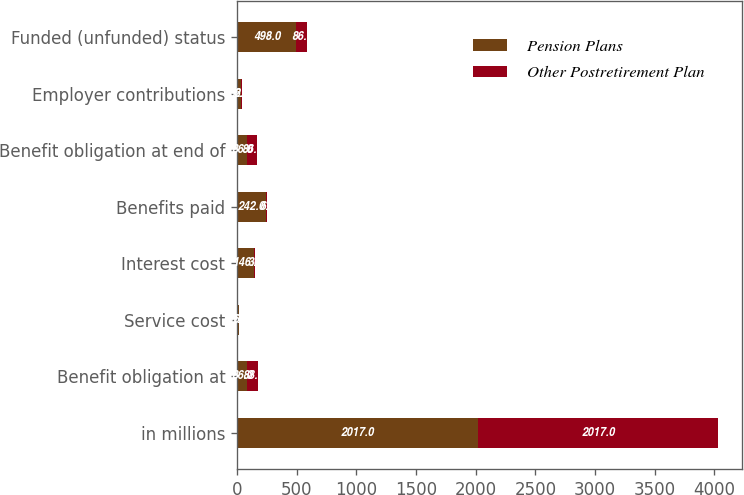<chart> <loc_0><loc_0><loc_500><loc_500><stacked_bar_chart><ecel><fcel>in millions<fcel>Benefit obligation at<fcel>Service cost<fcel>Interest cost<fcel>Benefits paid<fcel>Benefit obligation at end of<fcel>Employer contributions<fcel>Funded (unfunded) status<nl><fcel>Pension Plans<fcel>2017<fcel>86<fcel>16<fcel>146<fcel>242<fcel>86<fcel>32<fcel>498<nl><fcel>Other Postretirement Plan<fcel>2017<fcel>88<fcel>1<fcel>3<fcel>6<fcel>86<fcel>6<fcel>86<nl></chart> 